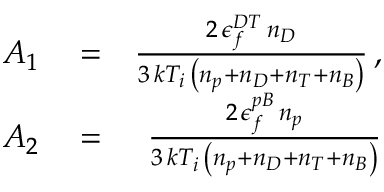<formula> <loc_0><loc_0><loc_500><loc_500>\begin{array} { r l r } { A _ { 1 } } & = } & { \frac { 2 \, \epsilon _ { f } ^ { D T } \, n _ { D } } { 3 \, k T _ { i } \, \left ( n _ { p } + n _ { D } + n _ { T } + n _ { B } \right ) } \, , } \\ { A _ { 2 } } & = } & { \frac { 2 \, \epsilon _ { f } ^ { p B } \, n _ { p } } { 3 \, k T _ { i } \, \left ( n _ { p } + n _ { D } + n _ { T } + n _ { B } \right ) } } \end{array}</formula> 